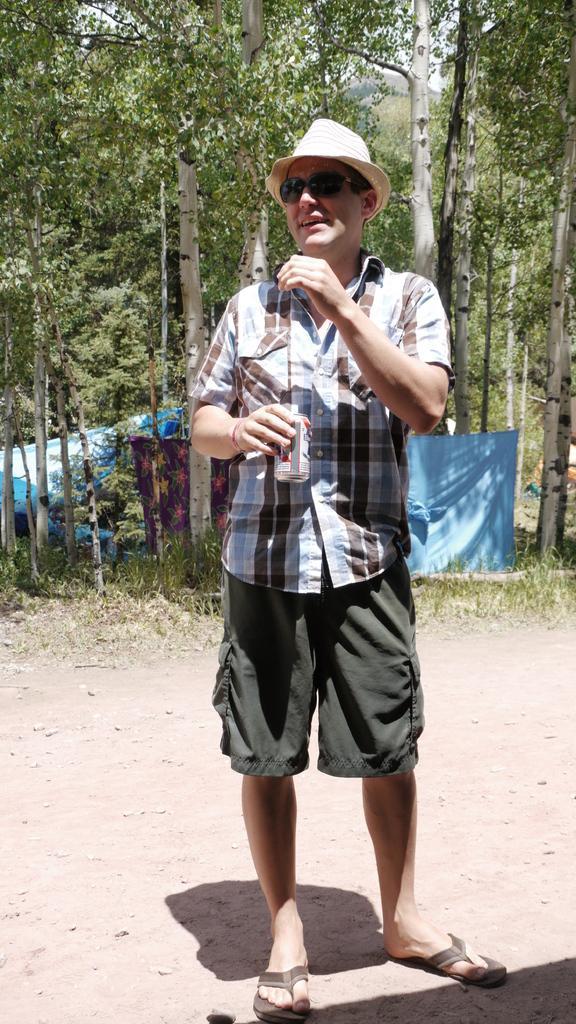In one or two sentences, can you explain what this image depicts? In this picture we can observe a man standing on the land. We can observe spectacles and a green color hat on his head. In the background there are trees and a blue color cloth. 